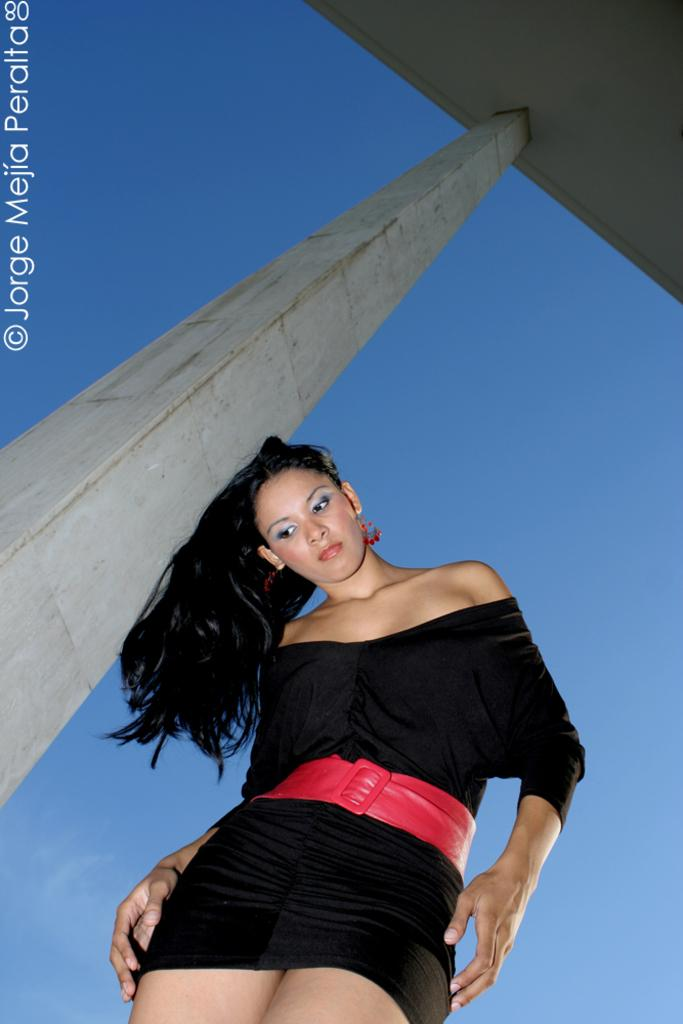Who is the main subject in the image? There is a woman in the middle of the image. What can be seen on the left side of the image? There appears to be a pillar on the left side of the image. What is visible in the background of the image? The sky is visible in the background of the image. How many children are playing with the pot in the image? There are no children or pots present in the image. What achievement did the woman in the image recently accomplish? The provided facts do not mention any achievements or accomplishments of the woman in the image. 